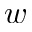Convert formula to latex. <formula><loc_0><loc_0><loc_500><loc_500>w</formula> 